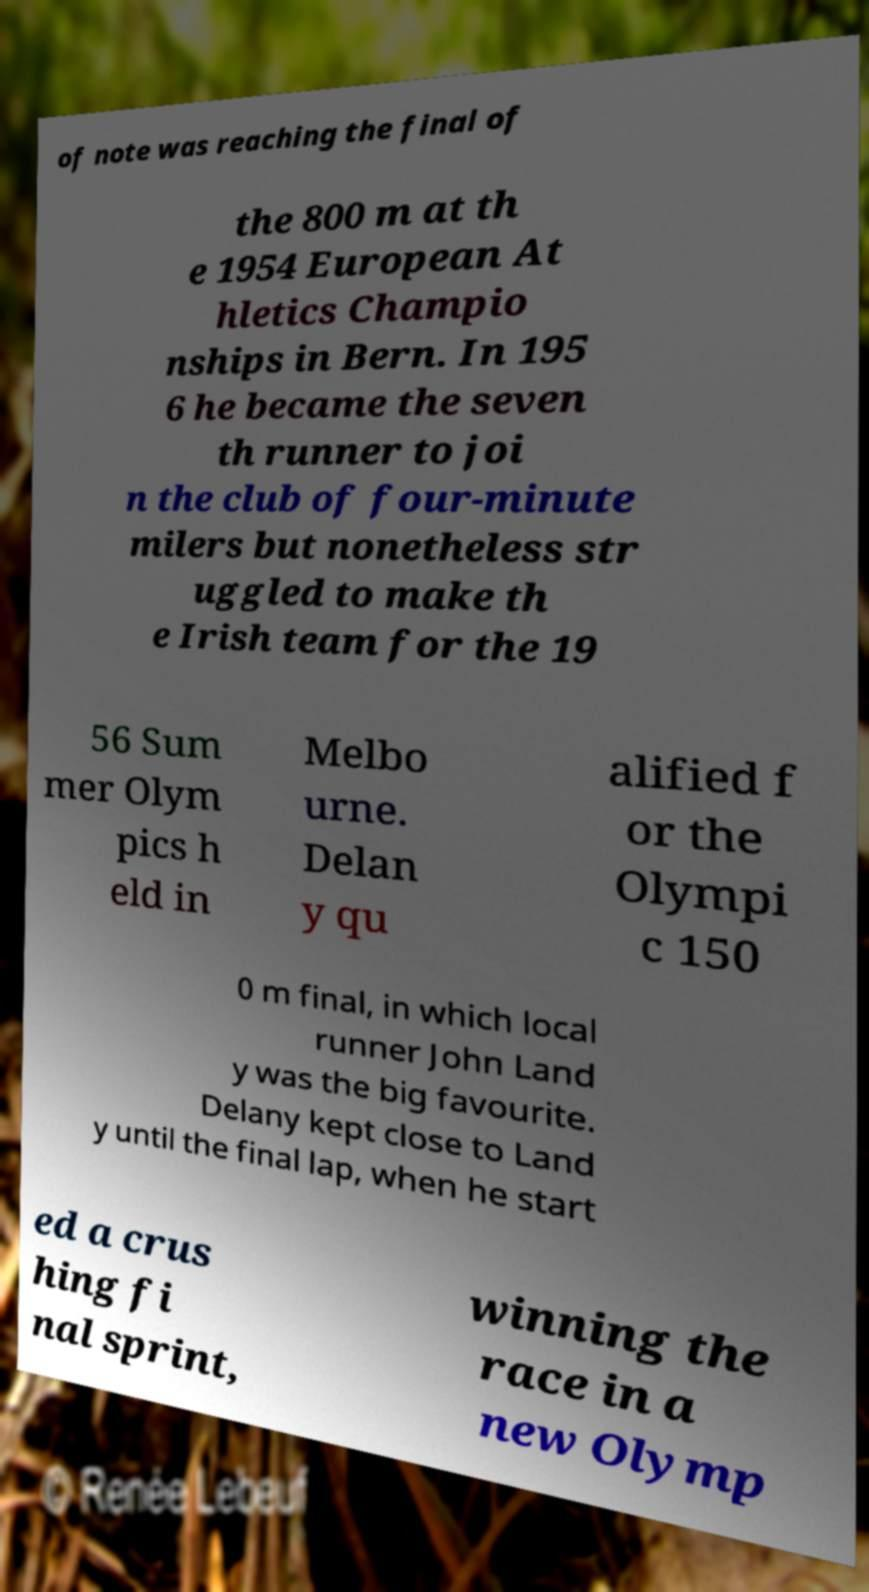There's text embedded in this image that I need extracted. Can you transcribe it verbatim? of note was reaching the final of the 800 m at th e 1954 European At hletics Champio nships in Bern. In 195 6 he became the seven th runner to joi n the club of four-minute milers but nonetheless str uggled to make th e Irish team for the 19 56 Sum mer Olym pics h eld in Melbo urne. Delan y qu alified f or the Olympi c 150 0 m final, in which local runner John Land y was the big favourite. Delany kept close to Land y until the final lap, when he start ed a crus hing fi nal sprint, winning the race in a new Olymp 